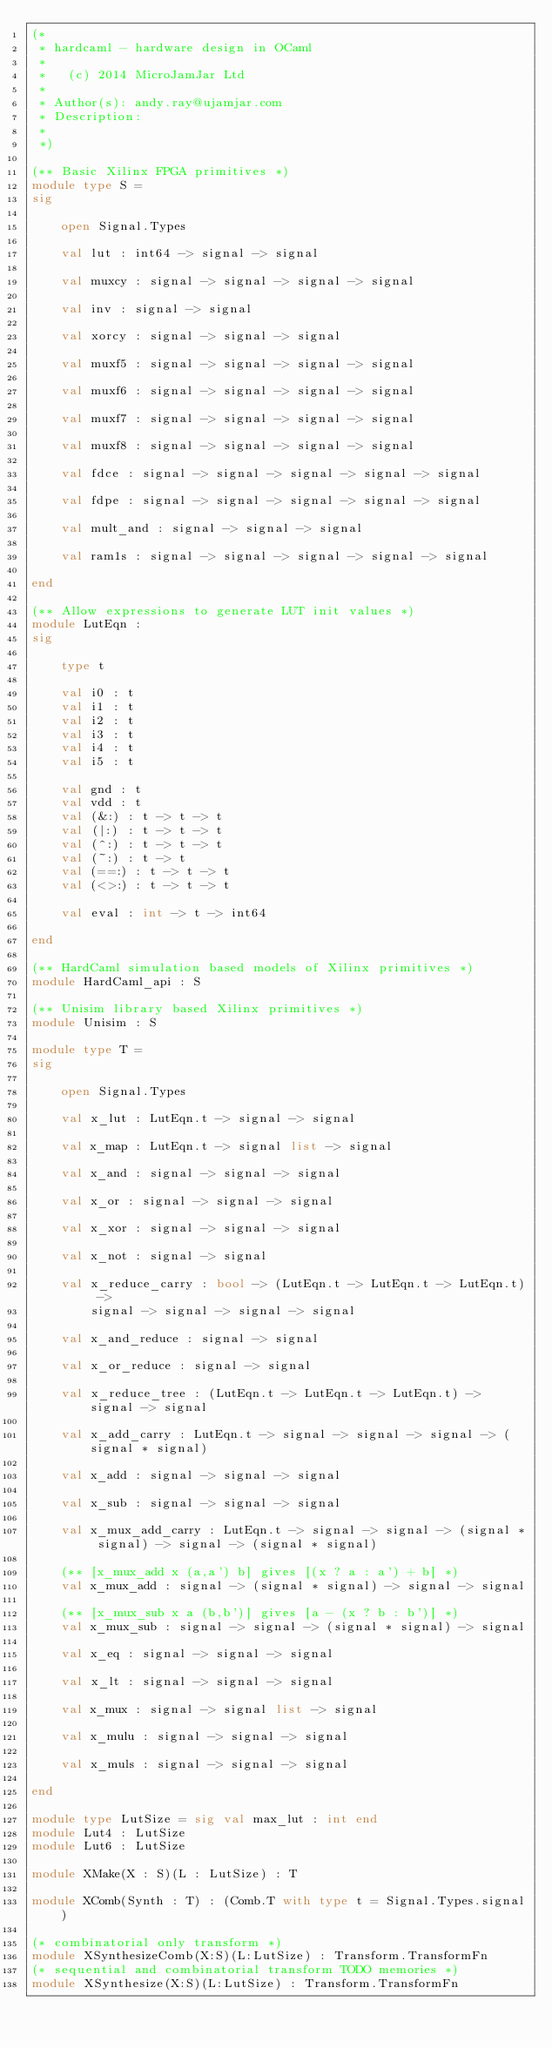Convert code to text. <code><loc_0><loc_0><loc_500><loc_500><_OCaml_>(* 
 * hardcaml - hardware design in OCaml
 *
 *   (c) 2014 MicroJamJar Ltd
 *
 * Author(s): andy.ray@ujamjar.com
 * Description: 
 *
 *)

(** Basic Xilinx FPGA primitives *)
module type S = 
sig

    open Signal.Types

    val lut : int64 -> signal -> signal

    val muxcy : signal -> signal -> signal -> signal

    val inv : signal -> signal

    val xorcy : signal -> signal -> signal

    val muxf5 : signal -> signal -> signal -> signal

    val muxf6 : signal -> signal -> signal -> signal

    val muxf7 : signal -> signal -> signal -> signal

    val muxf8 : signal -> signal -> signal -> signal

    val fdce : signal -> signal -> signal -> signal -> signal

    val fdpe : signal -> signal -> signal -> signal -> signal

    val mult_and : signal -> signal -> signal
    
    val ram1s : signal -> signal -> signal -> signal -> signal
    
end

(** Allow expressions to generate LUT init values *)
module LutEqn :
sig

    type t 

    val i0 : t
    val i1 : t
    val i2 : t
    val i3 : t
    val i4 : t
    val i5 : t

    val gnd : t
    val vdd : t
    val (&:) : t -> t -> t
    val (|:) : t -> t -> t
    val (^:) : t -> t -> t
    val (~:) : t -> t 
    val (==:) : t -> t -> t
    val (<>:) : t -> t -> t

    val eval : int -> t -> int64

end

(** HardCaml simulation based models of Xilinx primitives *)
module HardCaml_api : S

(** Unisim library based Xilinx primitives *)
module Unisim : S

module type T =
sig

    open Signal.Types

    val x_lut : LutEqn.t -> signal -> signal

    val x_map : LutEqn.t -> signal list -> signal
    
    val x_and : signal -> signal -> signal

    val x_or : signal -> signal -> signal

    val x_xor : signal -> signal -> signal

    val x_not : signal -> signal

    val x_reduce_carry : bool -> (LutEqn.t -> LutEqn.t -> LutEqn.t) -> 
        signal -> signal -> signal -> signal

    val x_and_reduce : signal -> signal
   
    val x_or_reduce : signal -> signal

    val x_reduce_tree : (LutEqn.t -> LutEqn.t -> LutEqn.t) -> signal -> signal

    val x_add_carry : LutEqn.t -> signal -> signal -> signal -> (signal * signal)

    val x_add : signal -> signal -> signal
  
    val x_sub : signal -> signal -> signal

    val x_mux_add_carry : LutEqn.t -> signal -> signal -> (signal * signal) -> signal -> (signal * signal)

    (** [x_mux_add x (a,a') b] gives [(x ? a : a') + b] *)
    val x_mux_add : signal -> (signal * signal) -> signal -> signal

    (** [x_mux_sub x a (b,b')] gives [a - (x ? b : b')] *)
    val x_mux_sub : signal -> signal -> (signal * signal) -> signal

    val x_eq : signal -> signal -> signal

    val x_lt : signal -> signal -> signal

    val x_mux : signal -> signal list -> signal

    val x_mulu : signal -> signal -> signal

    val x_muls : signal -> signal -> signal

end

module type LutSize = sig val max_lut : int end
module Lut4 : LutSize
module Lut6 : LutSize

module XMake(X : S)(L : LutSize) : T

module XComb(Synth : T) : (Comb.T with type t = Signal.Types.signal)

(* combinatorial only transform *)
module XSynthesizeComb(X:S)(L:LutSize) : Transform.TransformFn
(* sequential and combinatorial transform TODO memories *)
module XSynthesize(X:S)(L:LutSize) : Transform.TransformFn

</code> 